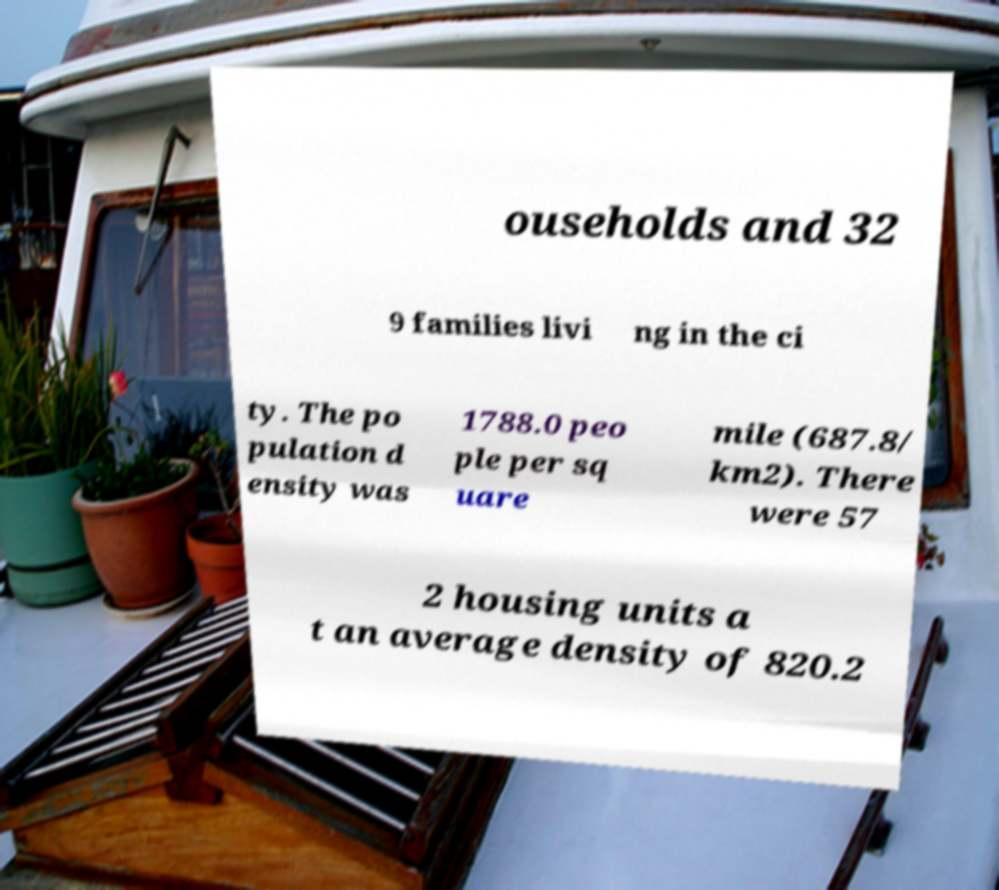I need the written content from this picture converted into text. Can you do that? ouseholds and 32 9 families livi ng in the ci ty. The po pulation d ensity was 1788.0 peo ple per sq uare mile (687.8/ km2). There were 57 2 housing units a t an average density of 820.2 